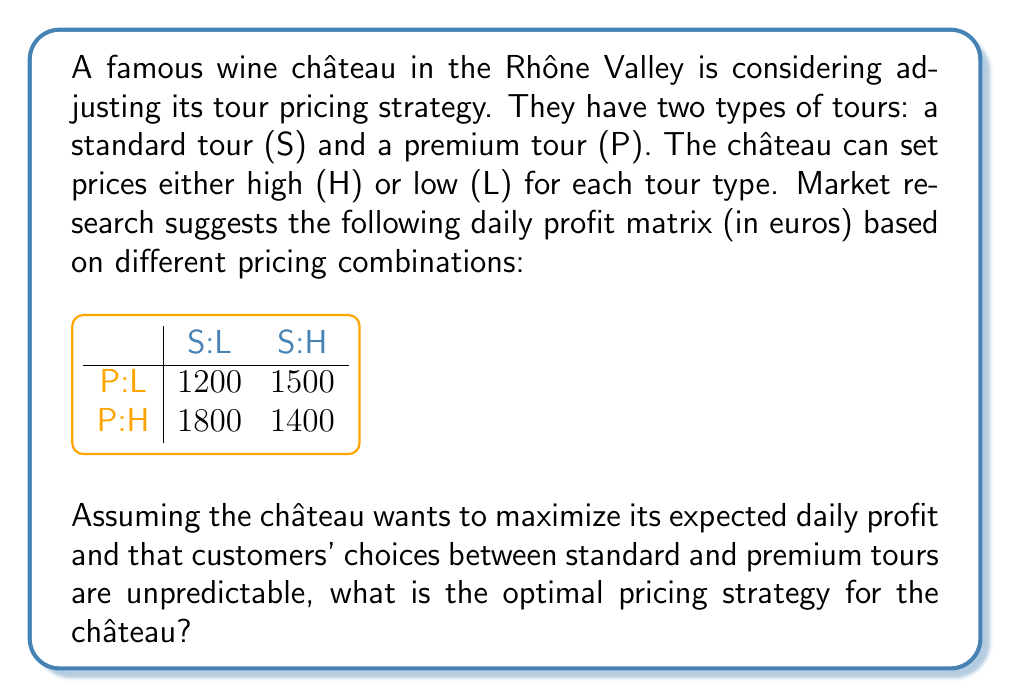What is the answer to this math problem? To solve this game theory problem, we need to find the Nash equilibrium using the minimax theorem. Here's the step-by-step process:

1) First, let's identify the players and their strategies:
   - Player 1 (row player): Premium tour pricing (P:L or P:H)
   - Player 2 (column player): Standard tour pricing (S:L or S:H)

2) We need to find the minimax and maximin values:

   For Player 1 (Premium tour):
   - If P:L, minimum possible outcome is 1200
   - If P:H, minimum possible outcome is 1400
   Maximin for Player 1 = max(1200, 1400) = 1400

   For Player 2 (Standard tour):
   - If S:L, maximum possible outcome is 1800
   - If S:H, maximum possible outcome is 1500
   Minimax for Player 2 = min(1800, 1500) = 1500

3) Since the maximin ≠ minimax, there's no pure strategy Nash equilibrium. We need to find a mixed strategy equilibrium.

4) Let's define probabilities:
   - Let $p$ be the probability of choosing P:L (so 1-$p$ is the probability of P:H)
   - Let $q$ be the probability of choosing S:L (so 1-$q$ is the probability of S:H)

5) For a mixed strategy equilibrium, the expected payoff for each of Player 2's strategies should be equal:

   $1200p + 1800(1-p) = 1500p + 1400(1-p)$

6) Solve this equation:
   $1200p + 1800 - 1800p = 1500p + 1400 - 1400p$
   $1800 - 600p = 1400 + 100p$
   $400 = 700p$
   $p = \frac{4}{7}$

7) Similarly, for Player 1's strategies to be equally attractive:

   $1200q + 1500(1-q) = 1800q + 1400(1-q)$

8) Solve this equation:
   $1200q + 1500 - 1500q = 1800q + 1400 - 1400q$
   $1500 - 300q = 1400 + 400q$
   $100 = 700q$
   $q = \frac{1}{7}$

Therefore, the optimal mixed strategy for the château is to set Premium tour prices low (P:L) with probability $\frac{4}{7}$ and high (P:H) with probability $\frac{3}{7}$, while setting Standard tour prices low (S:L) with probability $\frac{1}{7}$ and high (S:H) with probability $\frac{6}{7}$.
Answer: P:L with prob $\frac{4}{7}$, P:H with prob $\frac{3}{7}$; S:L with prob $\frac{1}{7}$, S:H with prob $\frac{6}{7}$ 